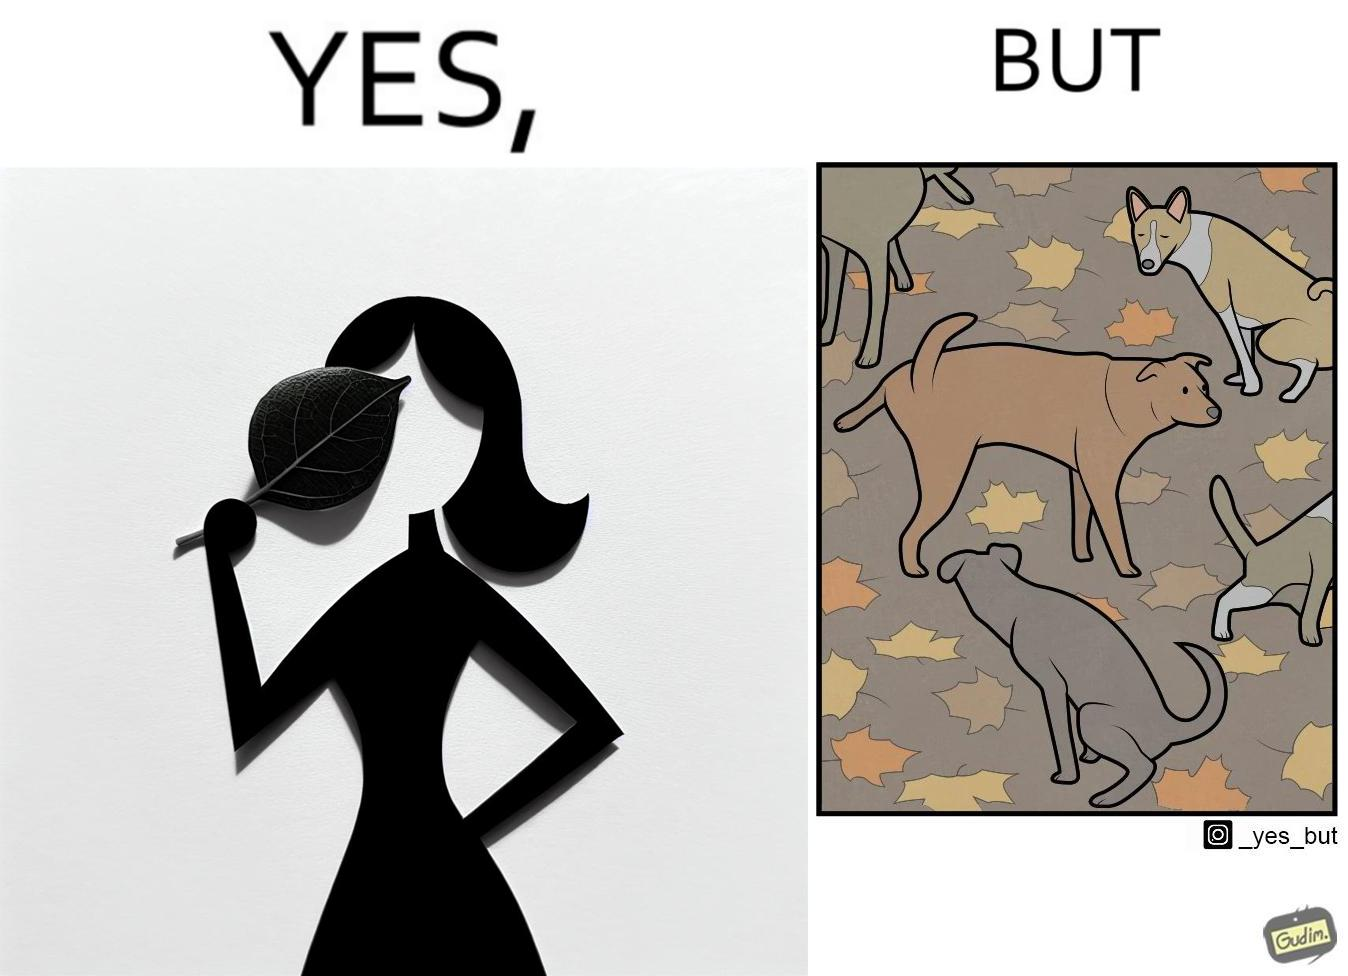What is the satirical meaning behind this image? The images are funny since it show a woman holding a leaf over half of her face for a good photo but unknown to her is thale fact the same leaf might have been defecated or urinated upon by dogs and other wild animals 